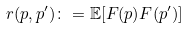Convert formula to latex. <formula><loc_0><loc_0><loc_500><loc_500>r ( p , p ^ { \prime } ) \colon = \mathbb { E } [ F ( p ) F ( p ^ { \prime } ) ]</formula> 